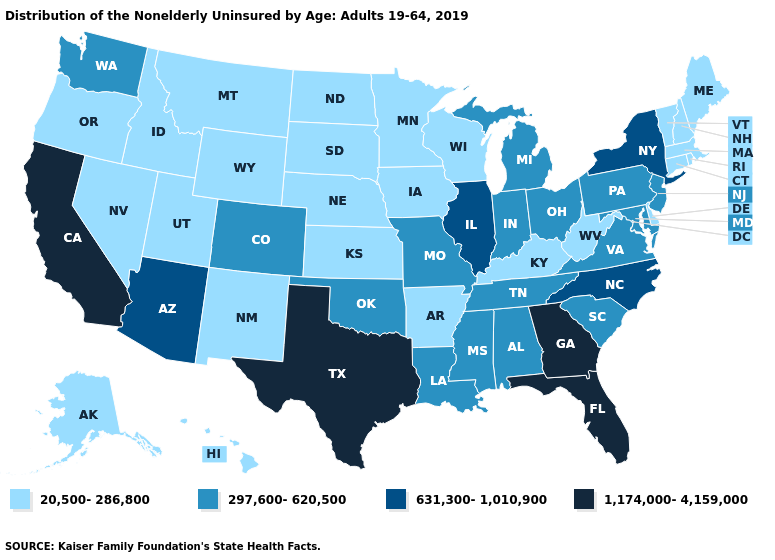What is the lowest value in the USA?
Concise answer only. 20,500-286,800. Which states have the highest value in the USA?
Write a very short answer. California, Florida, Georgia, Texas. Does Texas have the highest value in the USA?
Be succinct. Yes. What is the highest value in the Northeast ?
Write a very short answer. 631,300-1,010,900. Name the states that have a value in the range 631,300-1,010,900?
Be succinct. Arizona, Illinois, New York, North Carolina. Does Arkansas have the lowest value in the USA?
Be succinct. Yes. Name the states that have a value in the range 631,300-1,010,900?
Concise answer only. Arizona, Illinois, New York, North Carolina. Name the states that have a value in the range 1,174,000-4,159,000?
Give a very brief answer. California, Florida, Georgia, Texas. Which states hav the highest value in the West?
Answer briefly. California. What is the highest value in the USA?
Concise answer only. 1,174,000-4,159,000. What is the value of New York?
Quick response, please. 631,300-1,010,900. Among the states that border Maryland , does West Virginia have the lowest value?
Be succinct. Yes. Does Missouri have the same value as Illinois?
Give a very brief answer. No. Does South Carolina have a lower value than Connecticut?
Concise answer only. No. Which states have the lowest value in the South?
Write a very short answer. Arkansas, Delaware, Kentucky, West Virginia. 